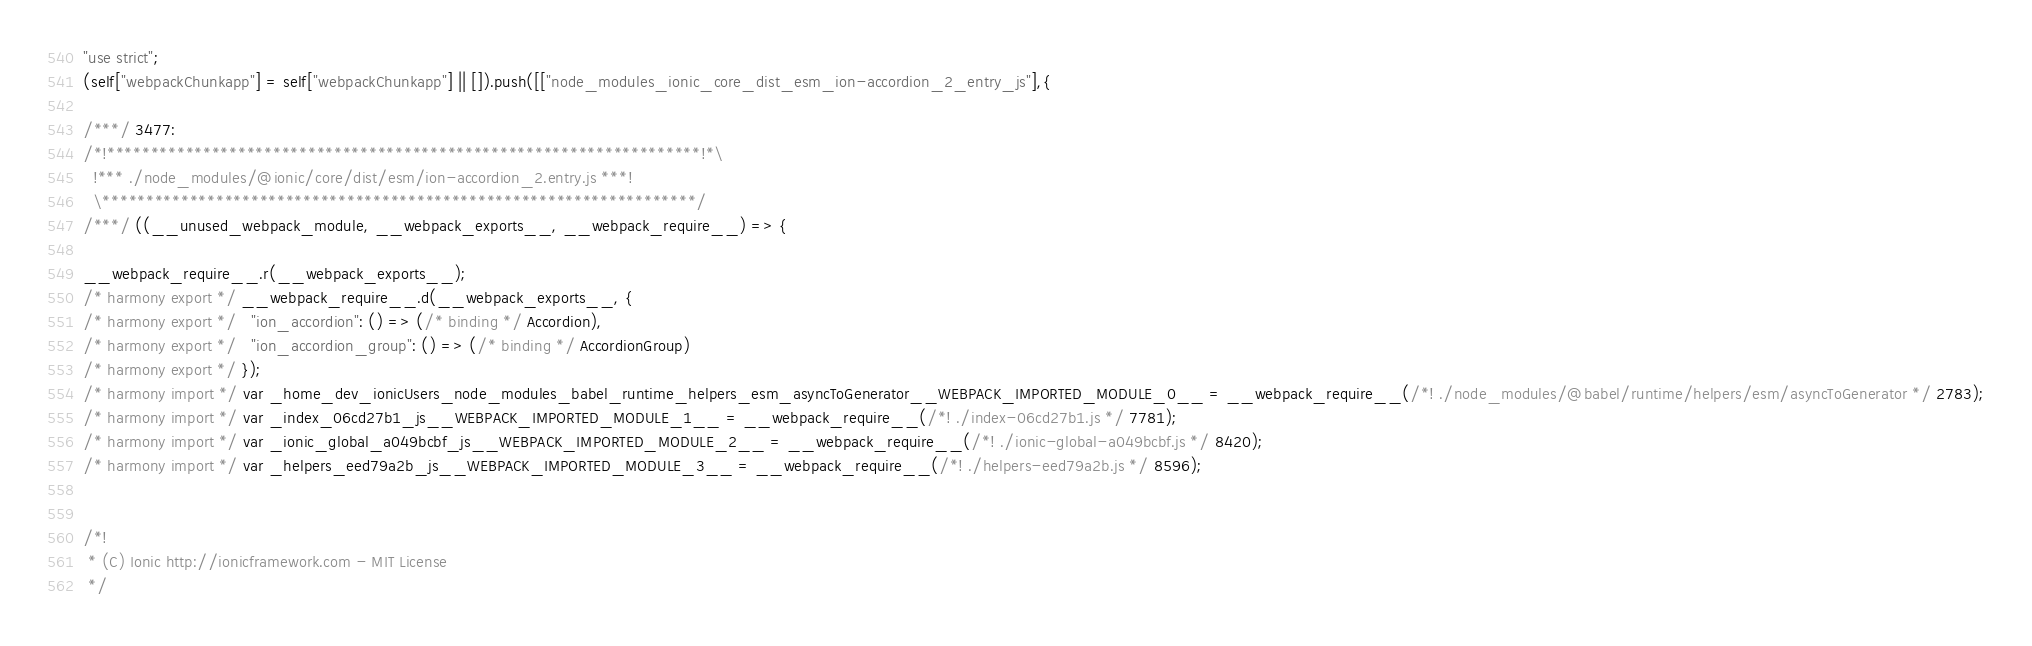<code> <loc_0><loc_0><loc_500><loc_500><_JavaScript_>"use strict";
(self["webpackChunkapp"] = self["webpackChunkapp"] || []).push([["node_modules_ionic_core_dist_esm_ion-accordion_2_entry_js"],{

/***/ 3477:
/*!********************************************************************!*\
  !*** ./node_modules/@ionic/core/dist/esm/ion-accordion_2.entry.js ***!
  \********************************************************************/
/***/ ((__unused_webpack_module, __webpack_exports__, __webpack_require__) => {

__webpack_require__.r(__webpack_exports__);
/* harmony export */ __webpack_require__.d(__webpack_exports__, {
/* harmony export */   "ion_accordion": () => (/* binding */ Accordion),
/* harmony export */   "ion_accordion_group": () => (/* binding */ AccordionGroup)
/* harmony export */ });
/* harmony import */ var _home_dev_ionicUsers_node_modules_babel_runtime_helpers_esm_asyncToGenerator__WEBPACK_IMPORTED_MODULE_0__ = __webpack_require__(/*! ./node_modules/@babel/runtime/helpers/esm/asyncToGenerator */ 2783);
/* harmony import */ var _index_06cd27b1_js__WEBPACK_IMPORTED_MODULE_1__ = __webpack_require__(/*! ./index-06cd27b1.js */ 7781);
/* harmony import */ var _ionic_global_a049bcbf_js__WEBPACK_IMPORTED_MODULE_2__ = __webpack_require__(/*! ./ionic-global-a049bcbf.js */ 8420);
/* harmony import */ var _helpers_eed79a2b_js__WEBPACK_IMPORTED_MODULE_3__ = __webpack_require__(/*! ./helpers-eed79a2b.js */ 8596);


/*!
 * (C) Ionic http://ionicframework.com - MIT License
 */


</code> 